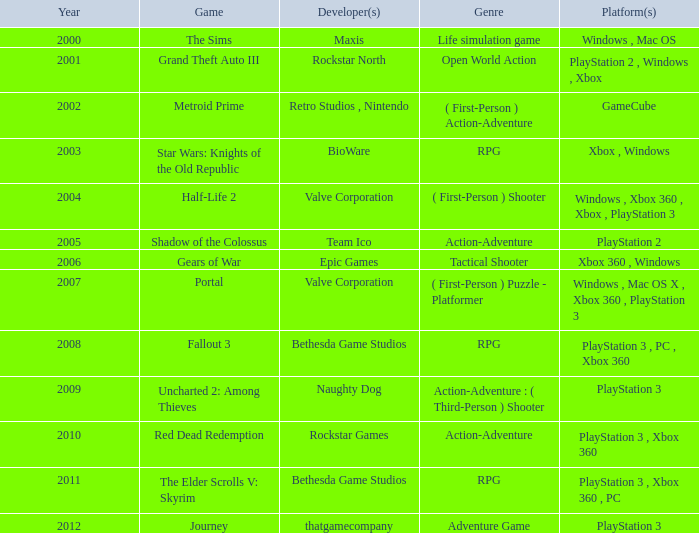What's the platform with rockstar games as the creator? PlayStation 3 , Xbox 360. 